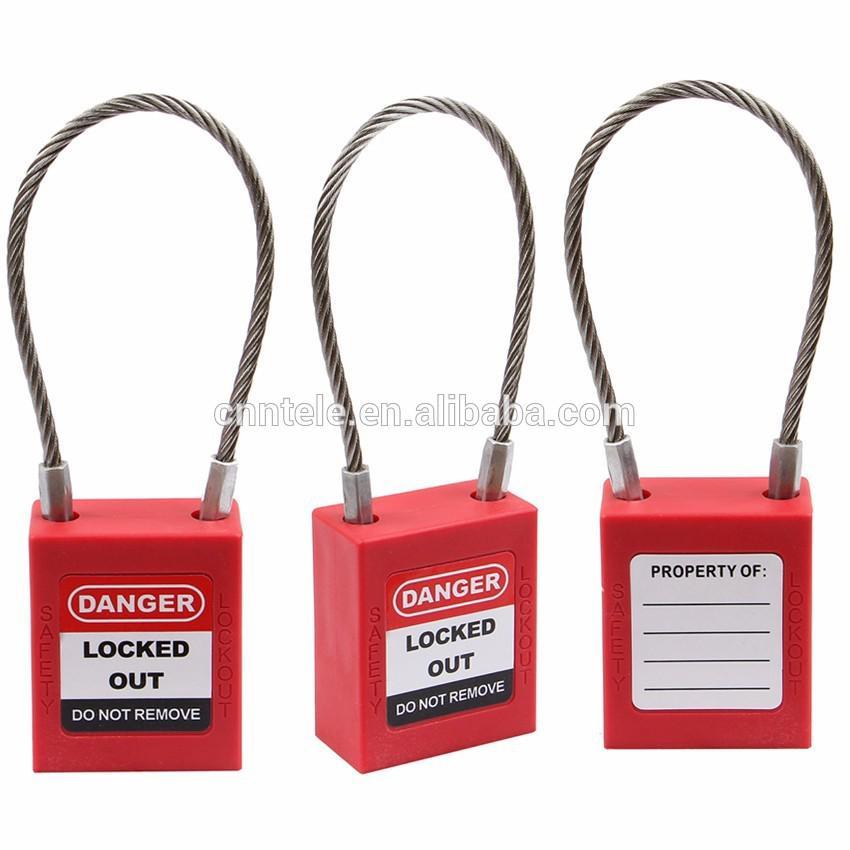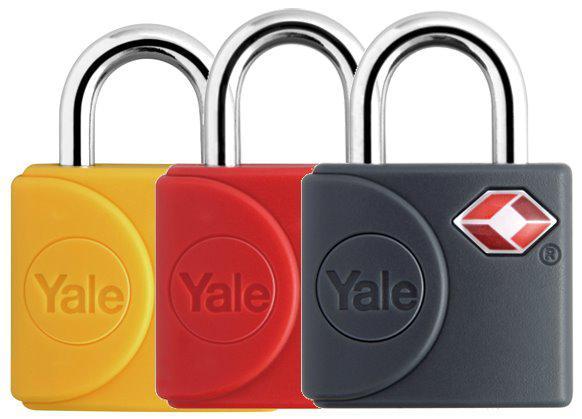The first image is the image on the left, the second image is the image on the right. For the images shown, is this caption "One of the locks on the left is black." true? Answer yes or no. No. 